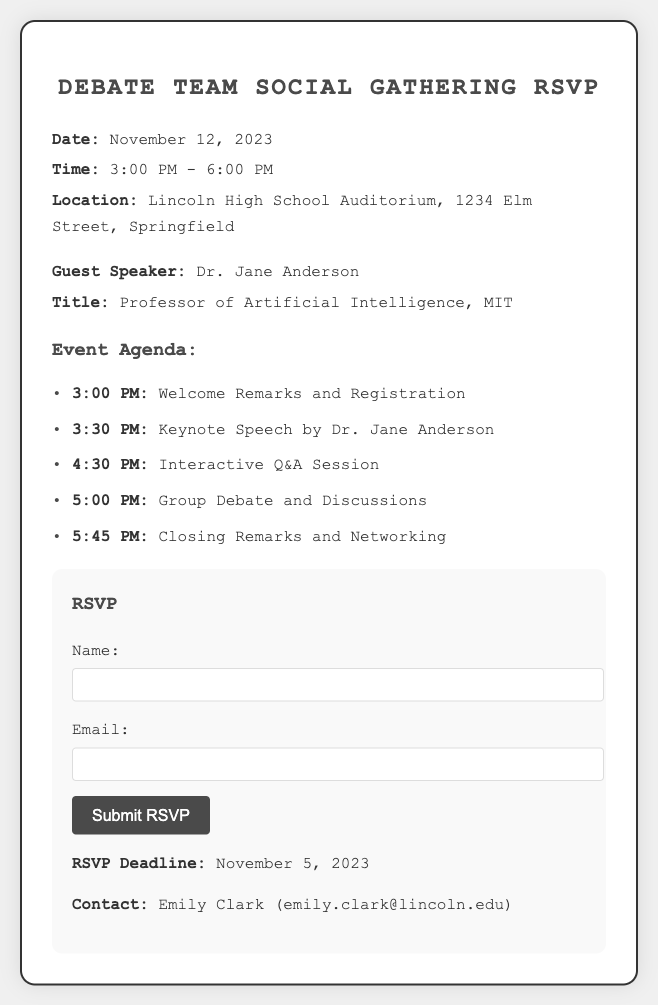What is the date of the event? The date of the event is listed in the document under event details.
Answer: November 12, 2023 Who is the guest speaker? The document provides information about the guest speaker in the speaker details section.
Answer: Dr. Jane Anderson What is the location of the gathering? The location can be found in the event details section of the document.
Answer: Lincoln High School Auditorium What time does the keynote speech start? The starting time for the keynote speech is mentioned in the agenda section.
Answer: 3:30 PM What is the RSVP deadline? The RSVP deadline is specified in the RSVP form section of the document.
Answer: November 5, 2023 What is the title of the guest speaker? The title is provided in the speaker details section pertaining to the guest speaker.
Answer: Professor of Artificial Intelligence, MIT How long is the group debate and discussions segment? Calculating from the agenda section, we can find the start and end time for this segment.
Answer: 45 minutes What will happen at 5:00 PM? This information is found in the agenda section detailing the schedule of events.
Answer: Group Debate and Discussions 